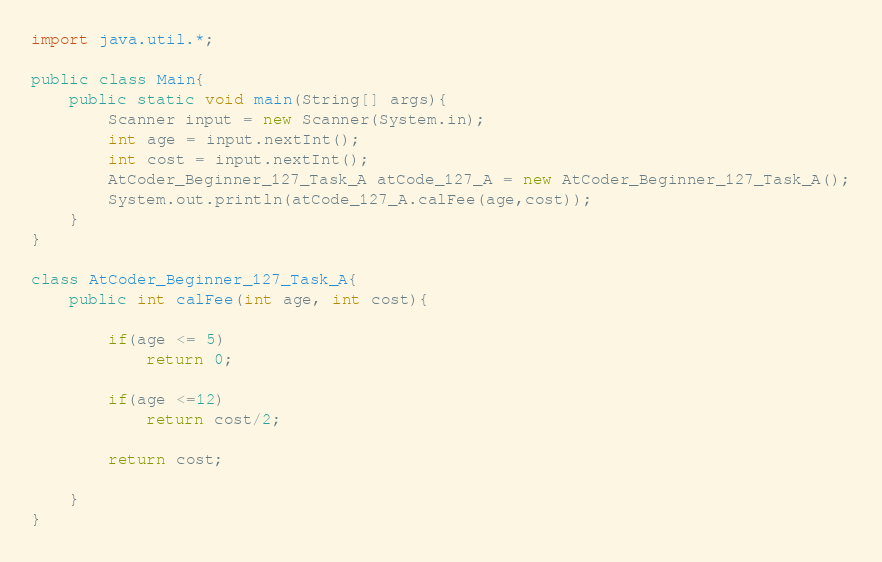Convert code to text. <code><loc_0><loc_0><loc_500><loc_500><_Java_>import java.util.*;

public class Main{
    public static void main(String[] args){
        Scanner input = new Scanner(System.in);
        int age = input.nextInt();
        int cost = input.nextInt();
        AtCoder_Beginner_127_Task_A atCode_127_A = new AtCoder_Beginner_127_Task_A();
        System.out.println(atCode_127_A.calFee(age,cost));
    }
}

class AtCoder_Beginner_127_Task_A{
    public int calFee(int age, int cost){
        
        if(age <= 5)
            return 0;
        
        if(age <=12)
            return cost/2;
        
        return cost;
        
    }
}</code> 